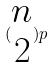<formula> <loc_0><loc_0><loc_500><loc_500>( \begin{matrix} n \\ 2 \end{matrix} ) p</formula> 